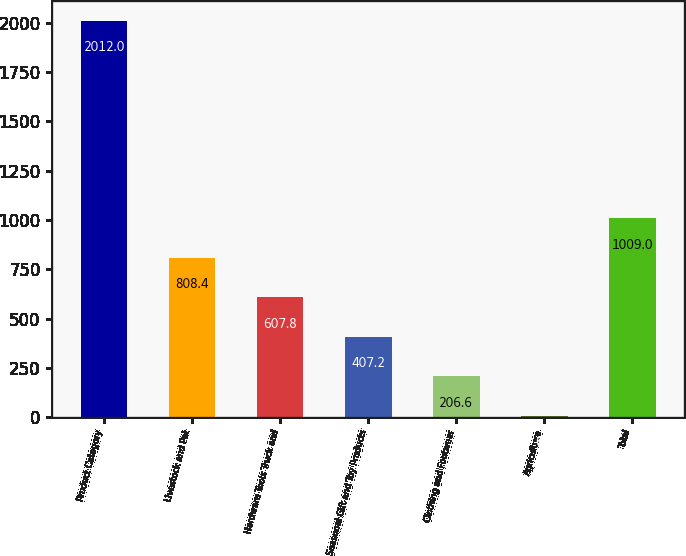Convert chart to OTSL. <chart><loc_0><loc_0><loc_500><loc_500><bar_chart><fcel>Product Category<fcel>Livestock and Pet<fcel>Hardware Tools Truck and<fcel>Seasonal Gift and Toy Products<fcel>Clothing and Footwear<fcel>Agriculture<fcel>Total<nl><fcel>2012<fcel>808.4<fcel>607.8<fcel>407.2<fcel>206.6<fcel>6<fcel>1009<nl></chart> 